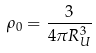Convert formula to latex. <formula><loc_0><loc_0><loc_500><loc_500>\rho _ { 0 } = \frac { 3 } { 4 \pi R _ { U } ^ { 3 } }</formula> 